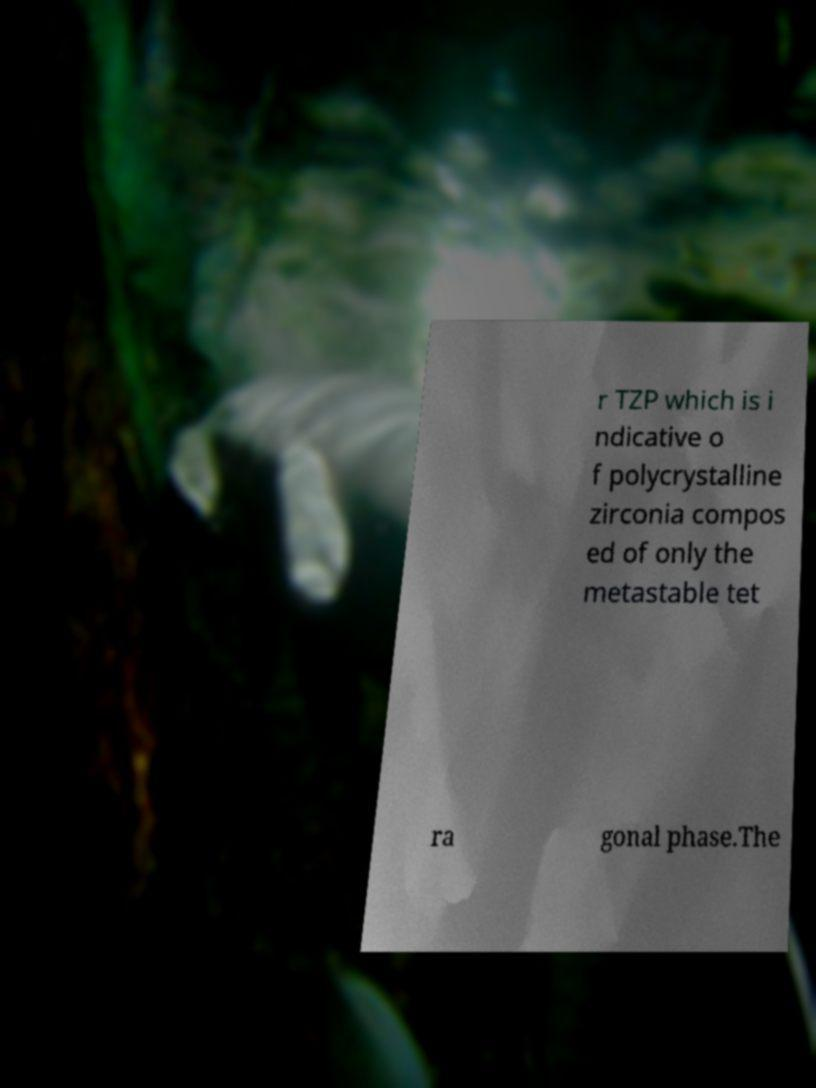Please identify and transcribe the text found in this image. r TZP which is i ndicative o f polycrystalline zirconia compos ed of only the metastable tet ra gonal phase.The 